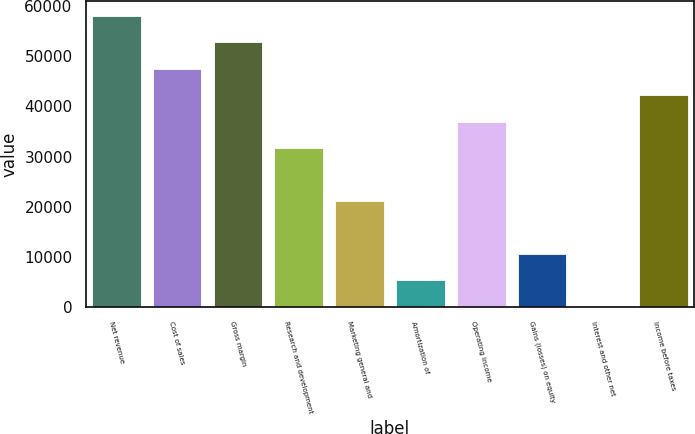<chart> <loc_0><loc_0><loc_500><loc_500><bar_chart><fcel>Net revenue<fcel>Cost of sales<fcel>Gross margin<fcel>Research and development<fcel>Marketing general and<fcel>Amortization of<fcel>Operating income<fcel>Gains (losses) on equity<fcel>Interest and other net<fcel>Income before taxes<nl><fcel>57963.7<fcel>47452.3<fcel>52708<fcel>31685.2<fcel>21173.8<fcel>5406.7<fcel>36940.9<fcel>10662.4<fcel>151<fcel>42196.6<nl></chart> 